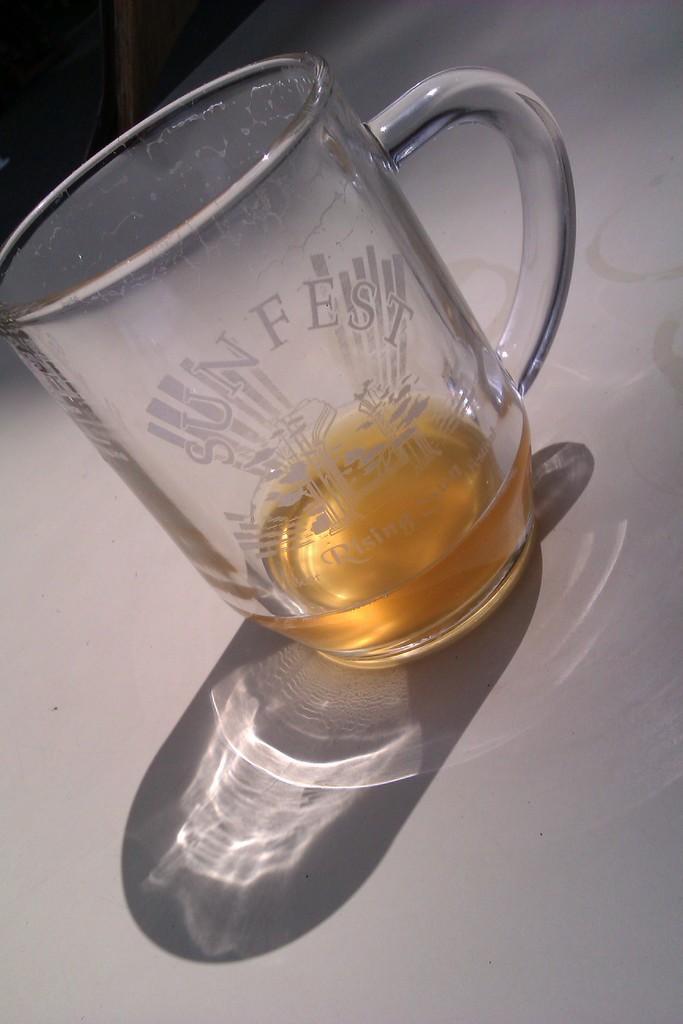In one or two sentences, can you explain what this image depicts? In the picture I can see a glass of drink and there is something written on the glass. 